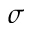<formula> <loc_0><loc_0><loc_500><loc_500>\sigma</formula> 